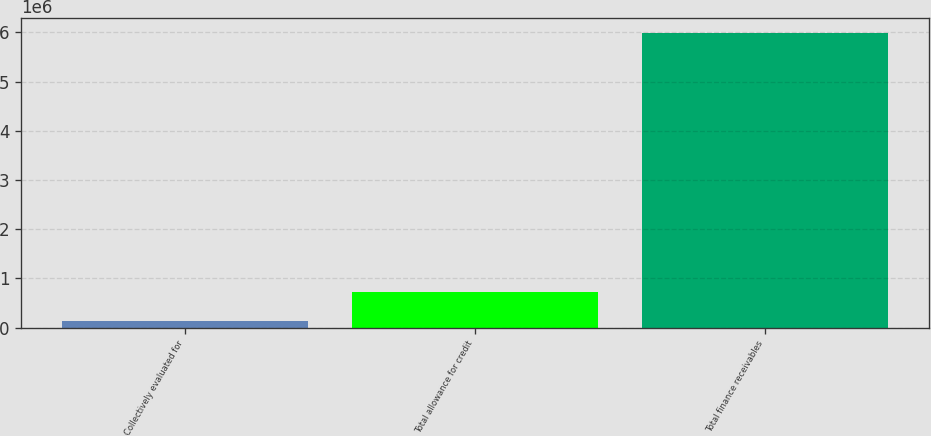<chart> <loc_0><loc_0><loc_500><loc_500><bar_chart><fcel>Collectively evaluated for<fcel>Total allowance for credit<fcel>Total finance receivables<nl><fcel>139320<fcel>724535<fcel>5.99147e+06<nl></chart> 